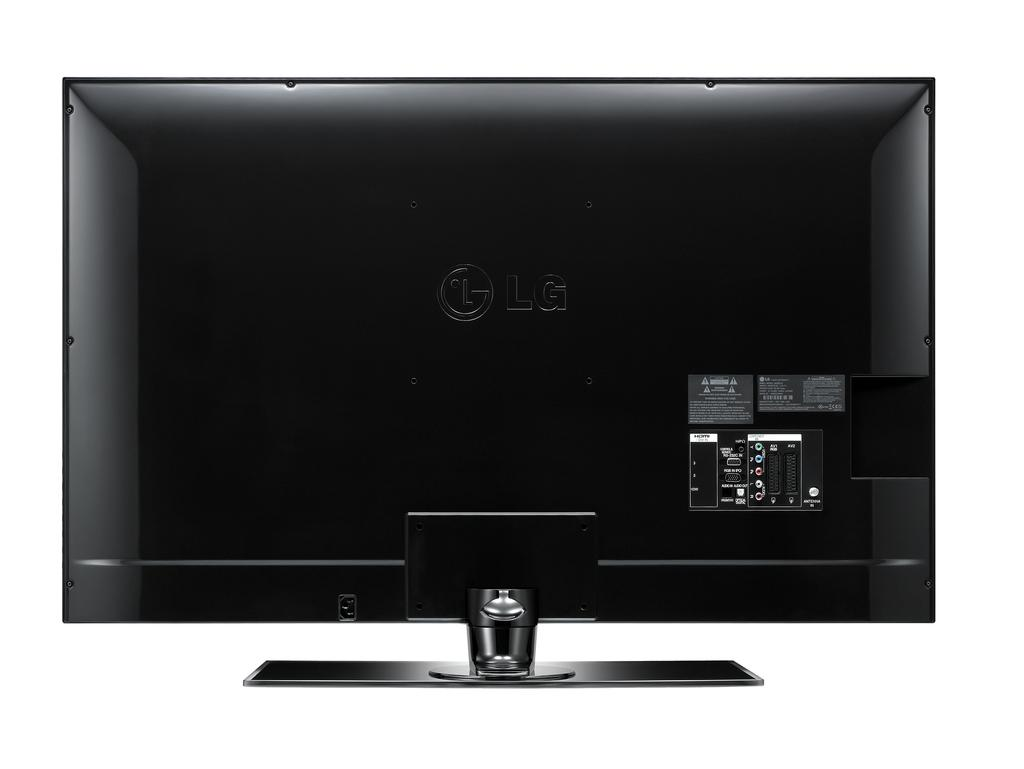<image>
Give a short and clear explanation of the subsequent image. The back of a black LG branded television with the inputs visible on the right. 